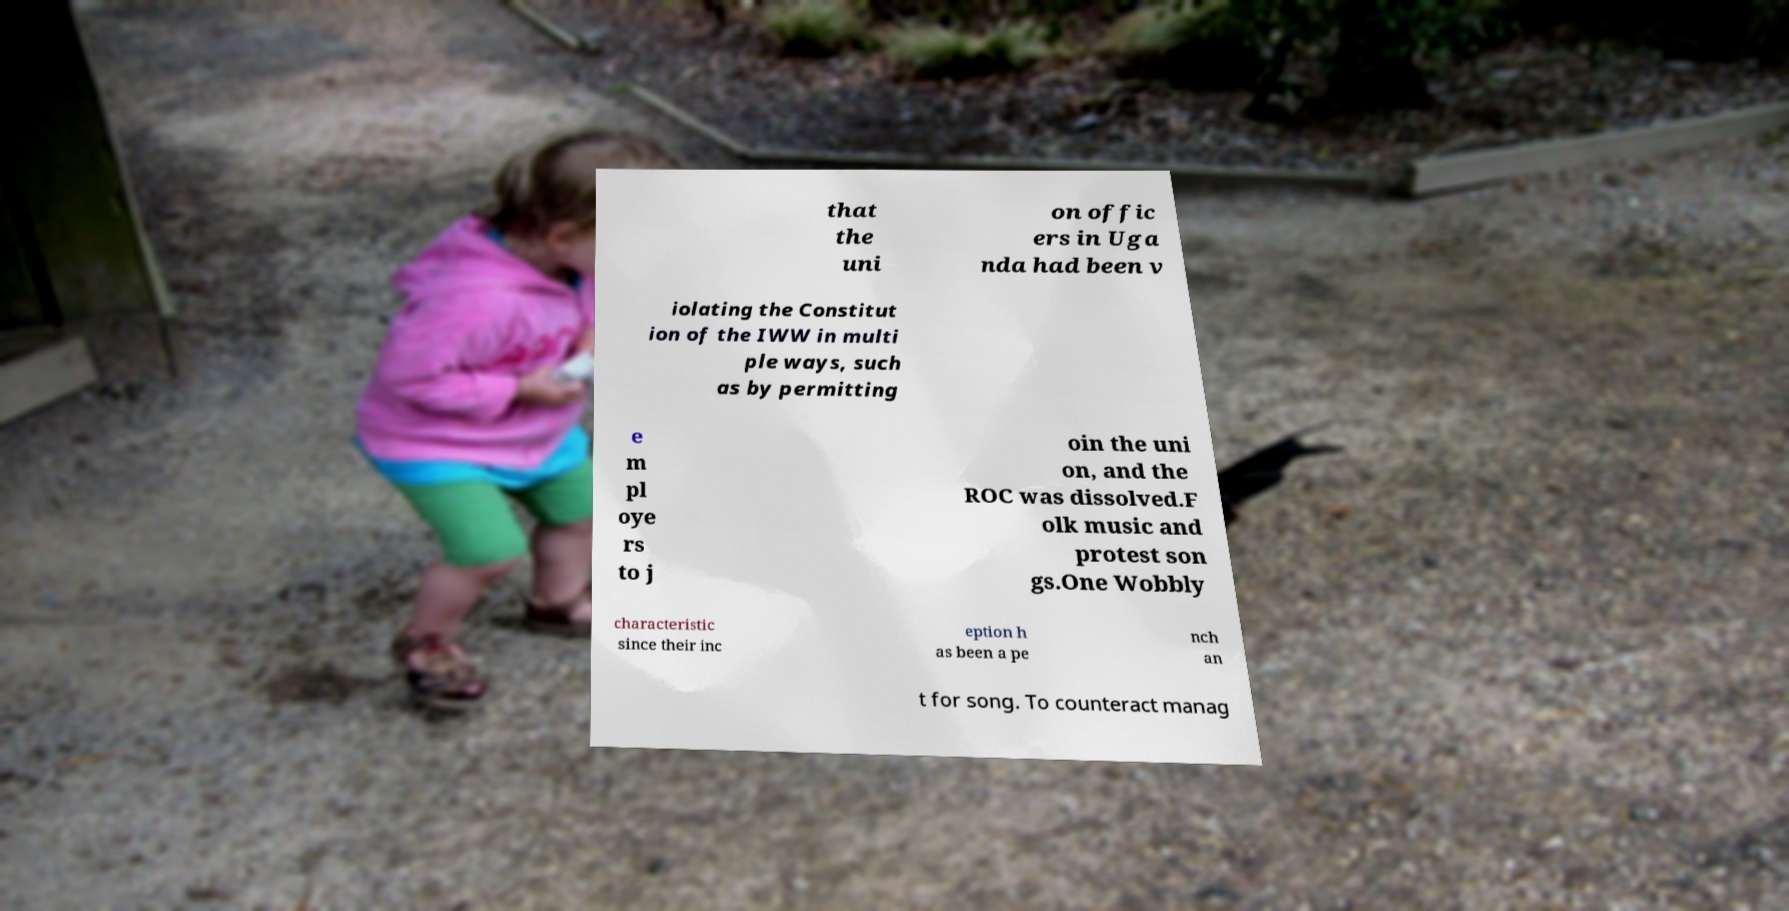What messages or text are displayed in this image? I need them in a readable, typed format. that the uni on offic ers in Uga nda had been v iolating the Constitut ion of the IWW in multi ple ways, such as by permitting e m pl oye rs to j oin the uni on, and the ROC was dissolved.F olk music and protest son gs.One Wobbly characteristic since their inc eption h as been a pe nch an t for song. To counteract manag 